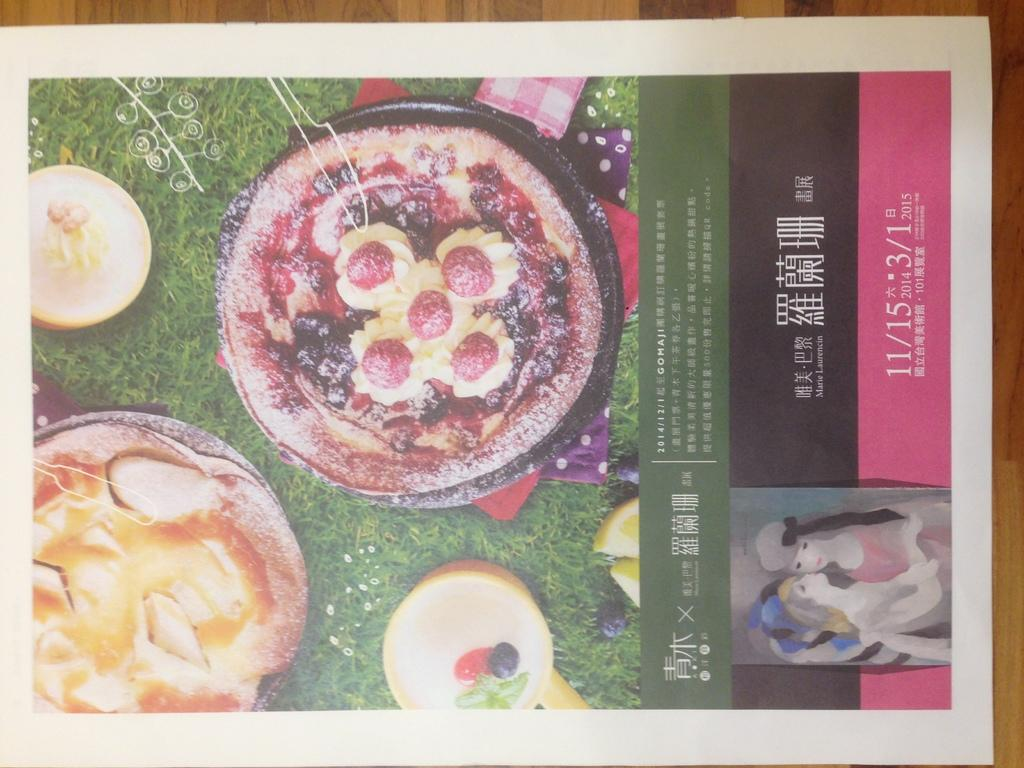<image>
Render a clear and concise summary of the photo. A poster for an event on November 15 features pictures of desserts. 